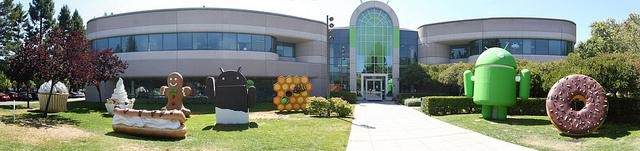What company's mascot can be seen on the right next to the donut?

Choices:
A) sony
B) android
C) apple
D) disney android 